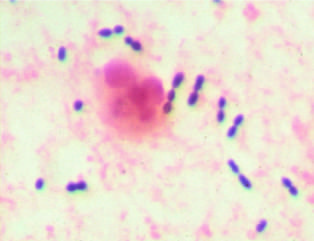re elongated cocci in pairs and short chains and a neutrophil evident?
Answer the question using a single word or phrase. Yes 